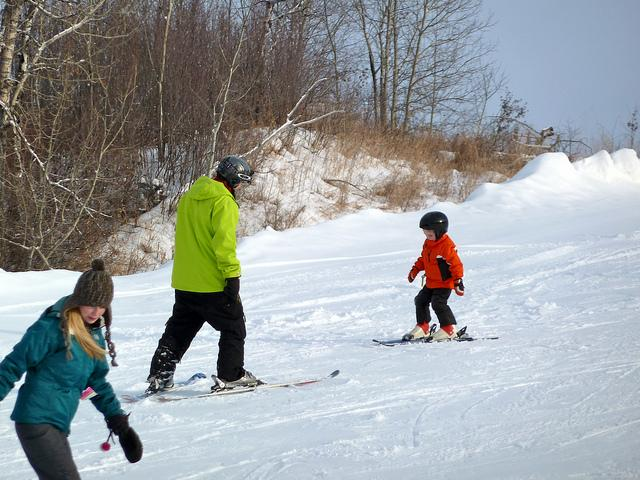The number of people here is called what? Please explain your reasoning. trio. There are three people in the scene. 